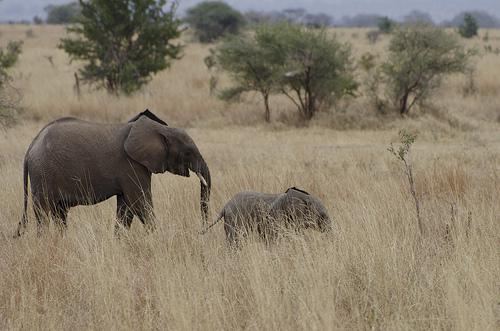Question: what are the elephants doing?
Choices:
A. Rolling in the mud.
B. Grazing.
C. Running.
D. Playing.
Answer with the letter. Answer: B Question: how many elephants are there?
Choices:
A. Three.
B. Four.
C. Two.
D. Five.
Answer with the letter. Answer: C Question: what is in the background?
Choices:
A. Bushes.
B. Hills.
C. Trees.
D. Meadow.
Answer with the letter. Answer: C Question: what is the big elephant holding with its trunk?
Choices:
A. The little elephant's tail.
B. Grass.
C. The little elephant's trunk.
D. A rock.
Answer with the letter. Answer: A Question: why are they grazing?
Choices:
A. They are eating.
B. Because they need to eat.
C. Because they are hungry.
D. Because they are traveling.
Answer with the letter. Answer: C 